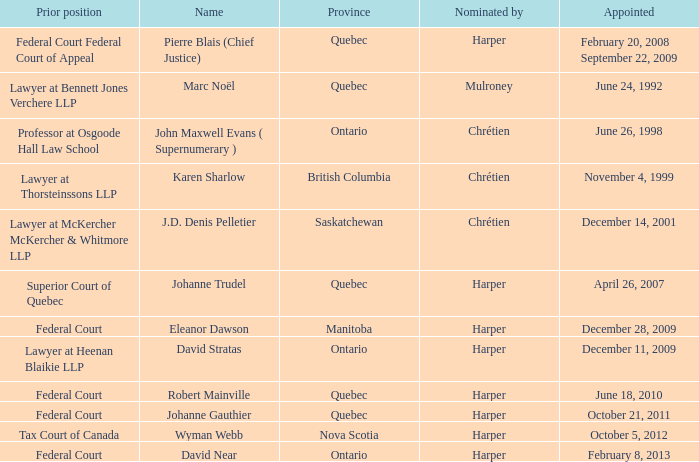Who was appointed on October 21, 2011 from Quebec? Johanne Gauthier. 